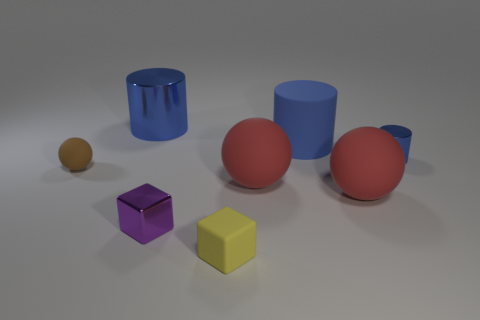Which geometric shapes can you identify in the image? In the image, there are three distinct geometric shapes: spheres (one brown, one red), cylinders (one blue, one light blue), and cubes (one purple, one yellow). 